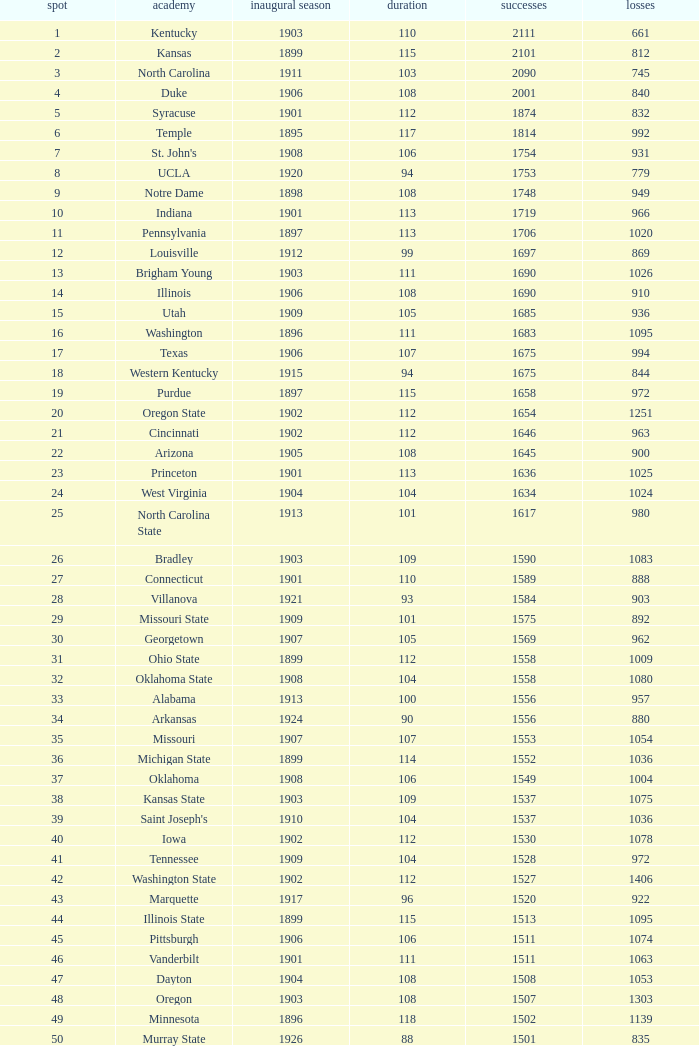What is the total number of rank with losses less than 992, North Carolina State College and a season greater than 101? 0.0. 